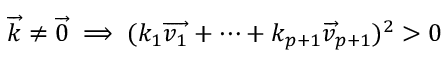Convert formula to latex. <formula><loc_0><loc_0><loc_500><loc_500>{ \overrightarrow { k } } \neq { \overrightarrow { 0 } } \implies ( k _ { 1 } { \overrightarrow { v _ { 1 } } } + \dots + k _ { p + 1 } { \overrightarrow { v } } _ { p + 1 } ) ^ { 2 } > 0</formula> 